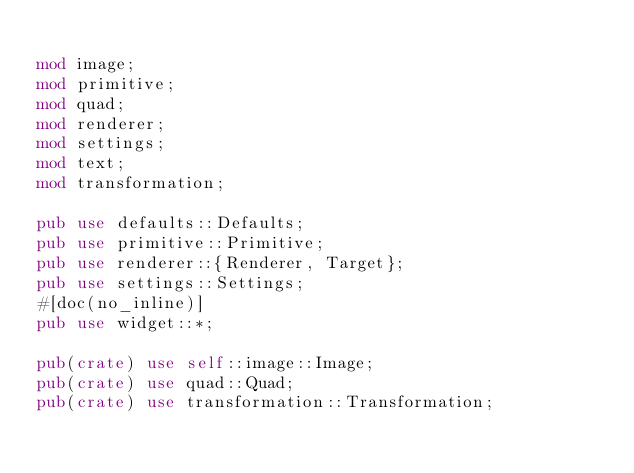Convert code to text. <code><loc_0><loc_0><loc_500><loc_500><_Rust_>
mod image;
mod primitive;
mod quad;
mod renderer;
mod settings;
mod text;
mod transformation;

pub use defaults::Defaults;
pub use primitive::Primitive;
pub use renderer::{Renderer, Target};
pub use settings::Settings;
#[doc(no_inline)]
pub use widget::*;

pub(crate) use self::image::Image;
pub(crate) use quad::Quad;
pub(crate) use transformation::Transformation;
</code> 